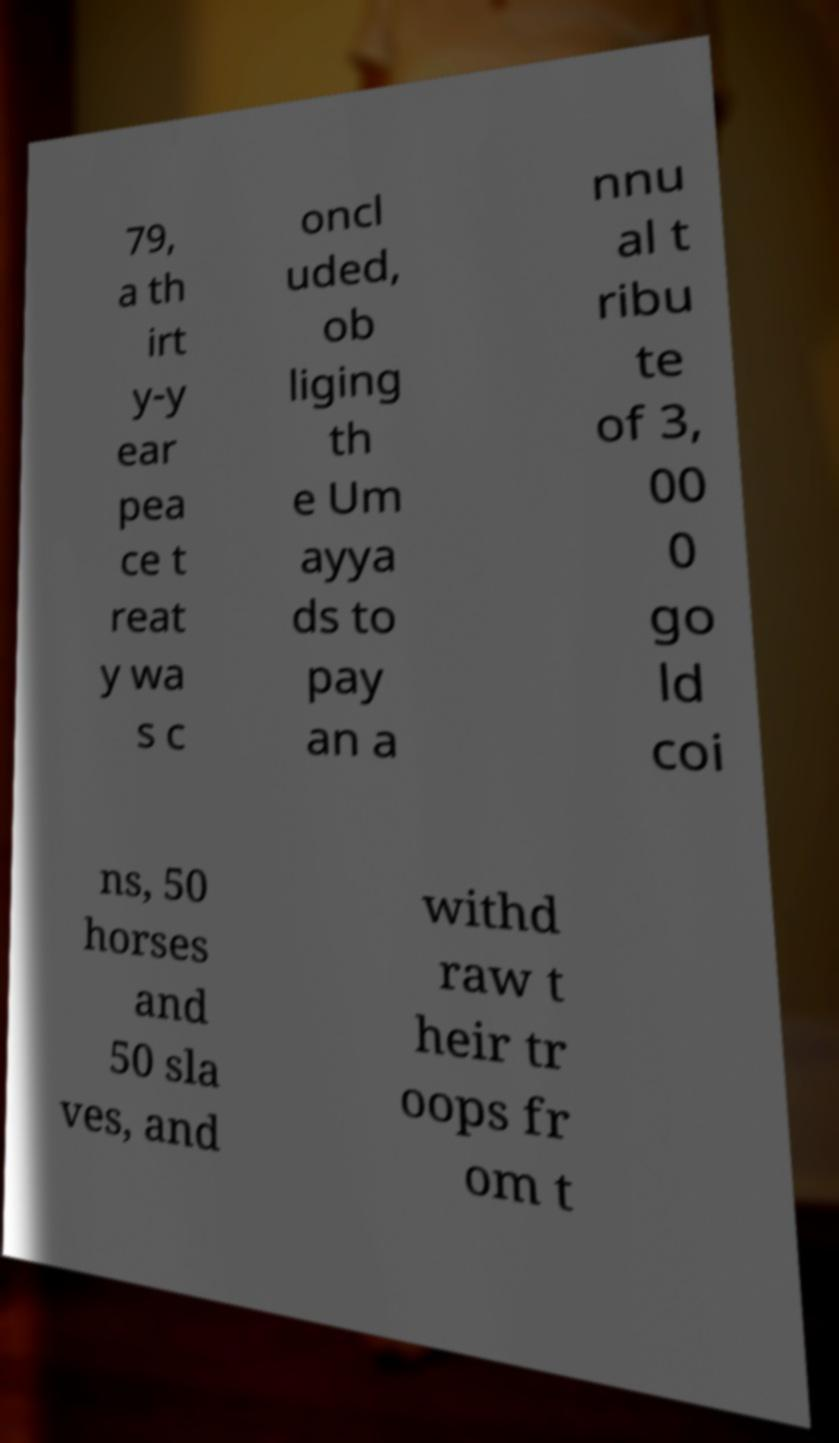There's text embedded in this image that I need extracted. Can you transcribe it verbatim? 79, a th irt y-y ear pea ce t reat y wa s c oncl uded, ob liging th e Um ayya ds to pay an a nnu al t ribu te of 3, 00 0 go ld coi ns, 50 horses and 50 sla ves, and withd raw t heir tr oops fr om t 